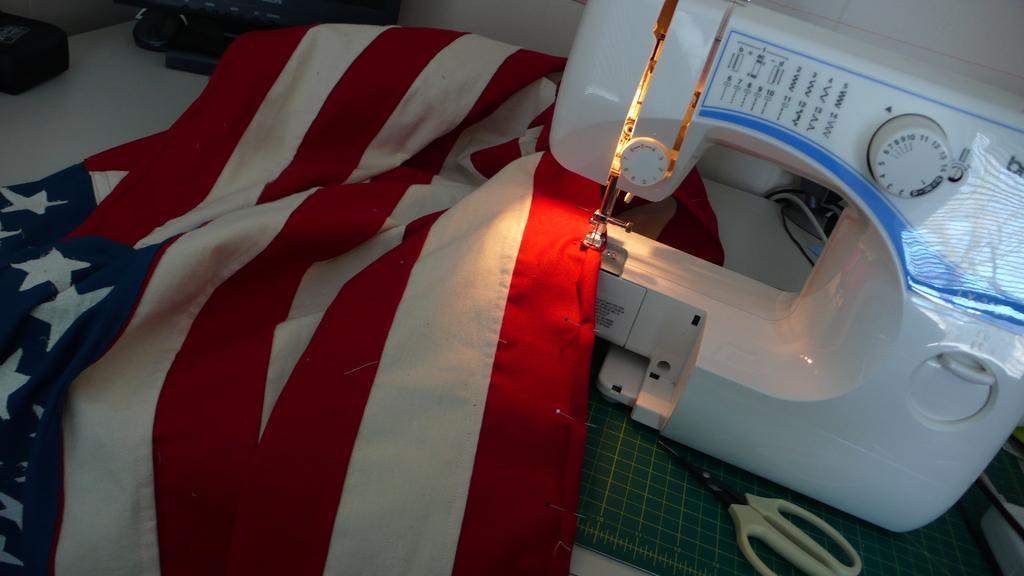Can you describe this image briefly? As we can see in the image there is a table. There is flag, sewing machine and scissors. The image is little dark. 